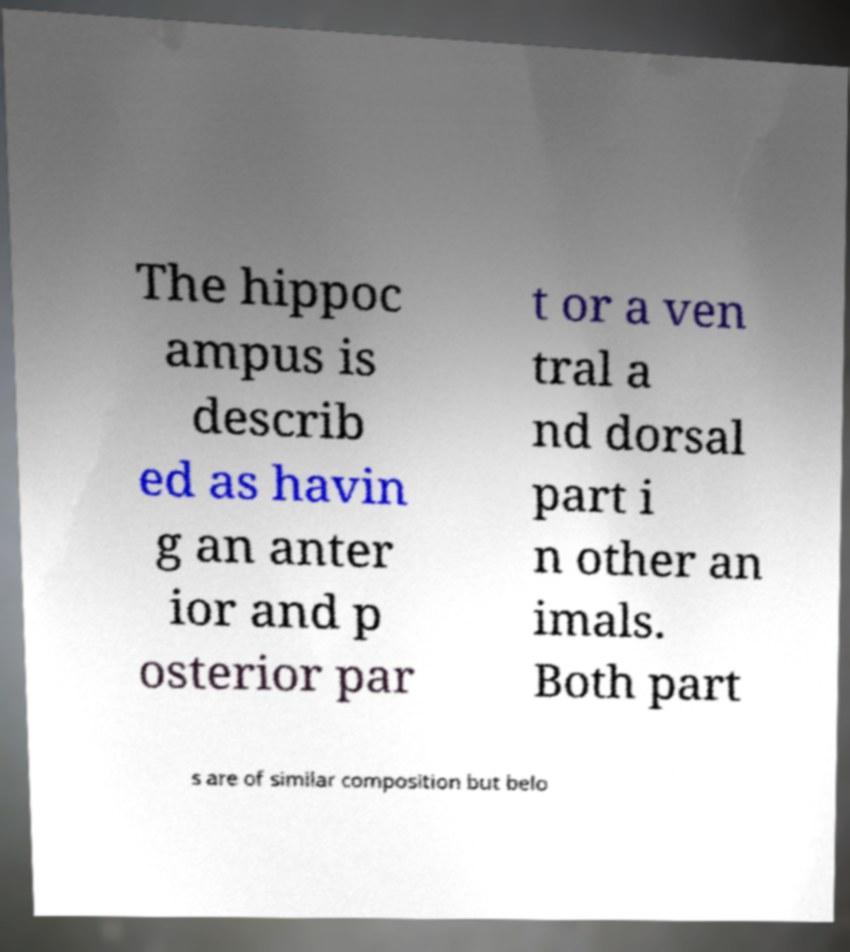Can you accurately transcribe the text from the provided image for me? The hippoc ampus is describ ed as havin g an anter ior and p osterior par t or a ven tral a nd dorsal part i n other an imals. Both part s are of similar composition but belo 